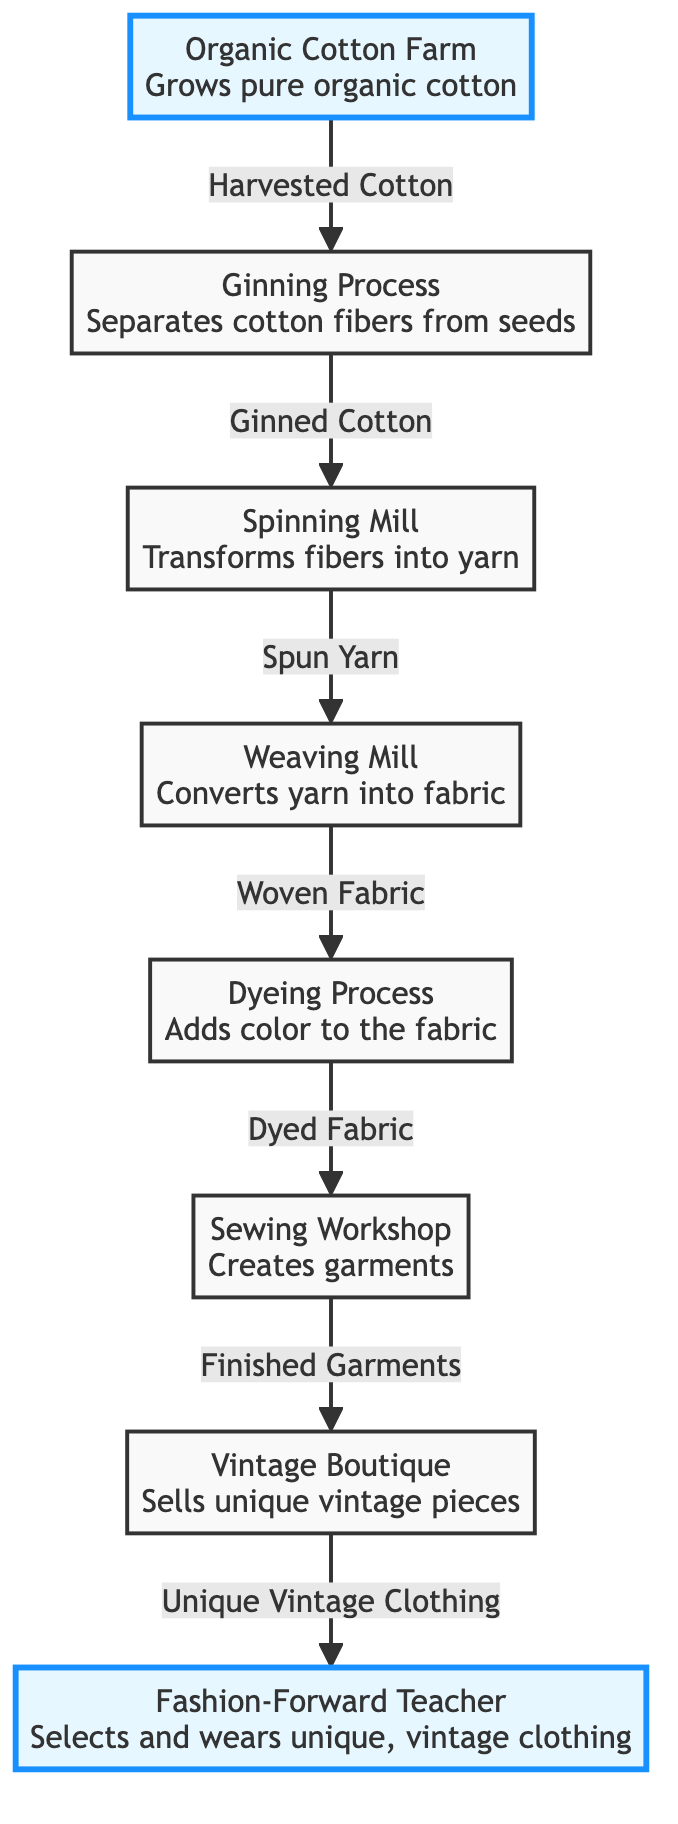What is the first step in the food chain? The first step in the food chain is the "Organic Cotton Farm," where organic cotton is grown.
Answer: Organic Cotton Farm How many processes are involved in transforming cotton into vintage clothing? There are six processes shown in the diagram: Ginning Process, Spinning Mill, Weaving Mill, Dyeing Process, Sewing Workshop, and Vintage Boutique.
Answer: Six What does the ginning process produce? The ginning process produces "Ginned Cotton," which is the cotton fibers separated from the seeds.
Answer: Ginned Cotton Which node follows the dyeing process? After the dyeing process, the next node is the "Sewing Workshop," where the dyed fabric is made into garments.
Answer: Sewing Workshop How does the consumer receive unique vintage clothing? The consumer receives unique vintage clothing from the "Vintage Boutique," which sells the finished garments created in earlier processes.
Answer: Vintage Boutique What type of garments are made in the sewing workshop? The sewing workshop produces "Finished Garments," which are the final products before reaching the boutique.
Answer: Finished Garments What is the last step in this organic cotton food chain? The last step in the food chain is the consumer selecting and wearing unique vintage clothing, concluding the process.
Answer: Consumer What is the primary input that starts the food chain? The primary input that starts the food chain is "Harvested Cotton," which comes from the organic cotton farm after harvest.
Answer: Harvested Cotton Which process adds color to the fabric? The dyeing process is responsible for adding color to the fabric in the flow of the food chain.
Answer: Dyeing Process 